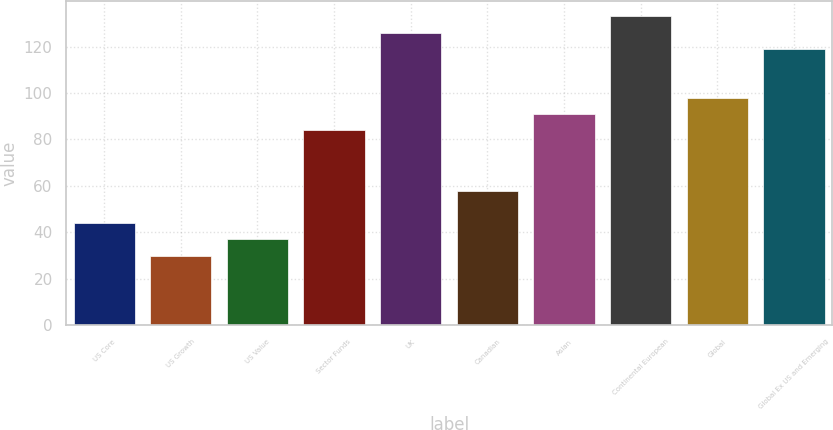Convert chart. <chart><loc_0><loc_0><loc_500><loc_500><bar_chart><fcel>US Core<fcel>US Growth<fcel>US Value<fcel>Sector Funds<fcel>UK<fcel>Canadian<fcel>Asian<fcel>Continental European<fcel>Global<fcel>Global Ex US and Emerging<nl><fcel>44<fcel>30<fcel>37<fcel>84<fcel>126<fcel>58<fcel>91<fcel>133<fcel>98<fcel>119<nl></chart> 